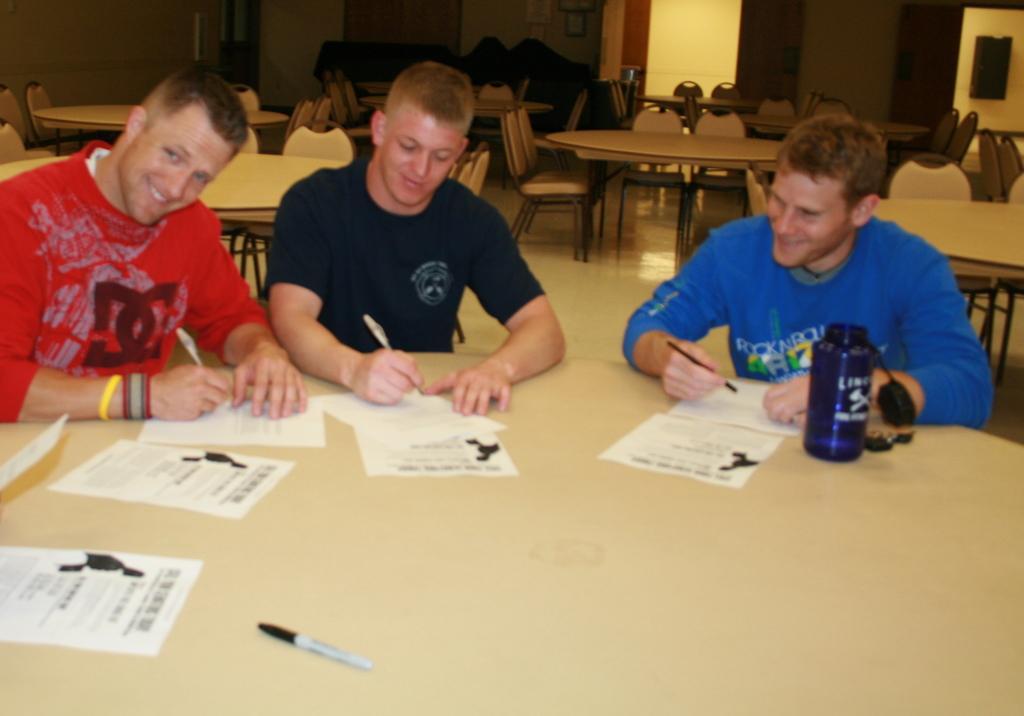In one or two sentences, can you explain what this image depicts? In this image there are a group of people sitting around the table and writing something on paper, also there is a paper and bottle on the bottle, behind them there are so many empty chairs and tables. 